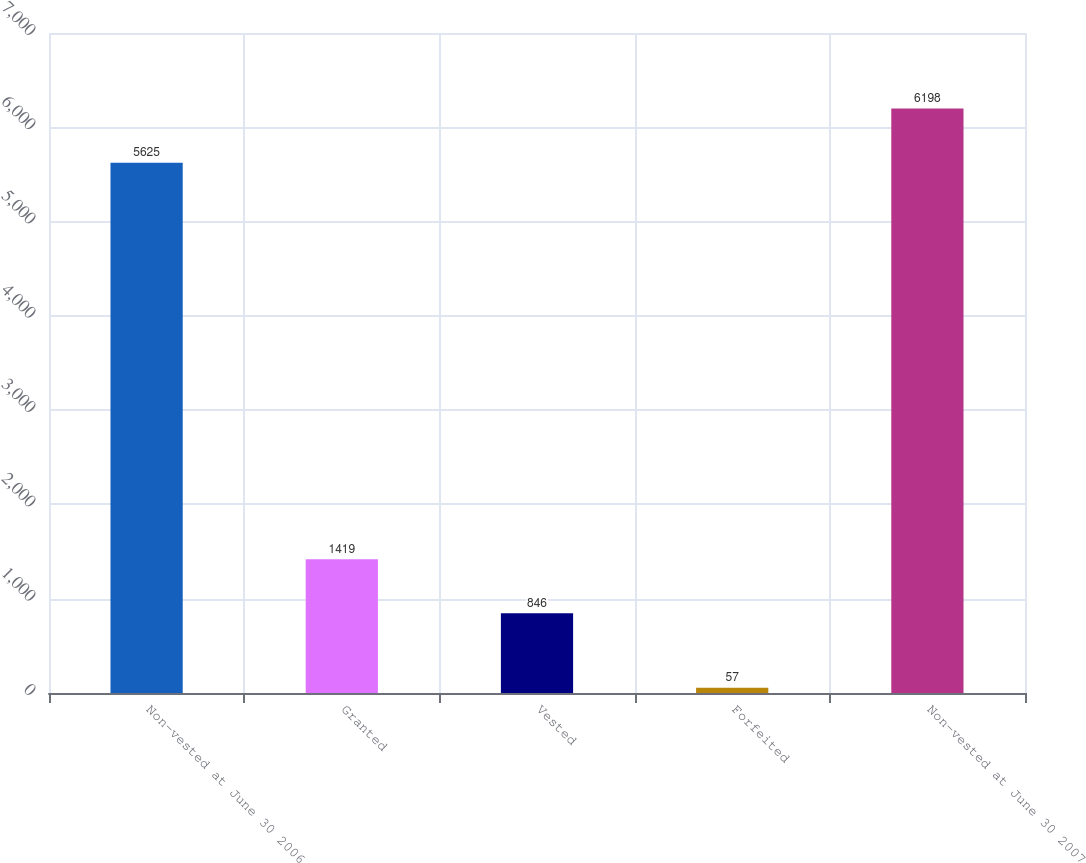Convert chart to OTSL. <chart><loc_0><loc_0><loc_500><loc_500><bar_chart><fcel>Non-vested at June 30 2006<fcel>Granted<fcel>Vested<fcel>Forfeited<fcel>Non-vested at June 30 2007<nl><fcel>5625<fcel>1419<fcel>846<fcel>57<fcel>6198<nl></chart> 